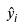Convert formula to latex. <formula><loc_0><loc_0><loc_500><loc_500>\hat { y } _ { i }</formula> 